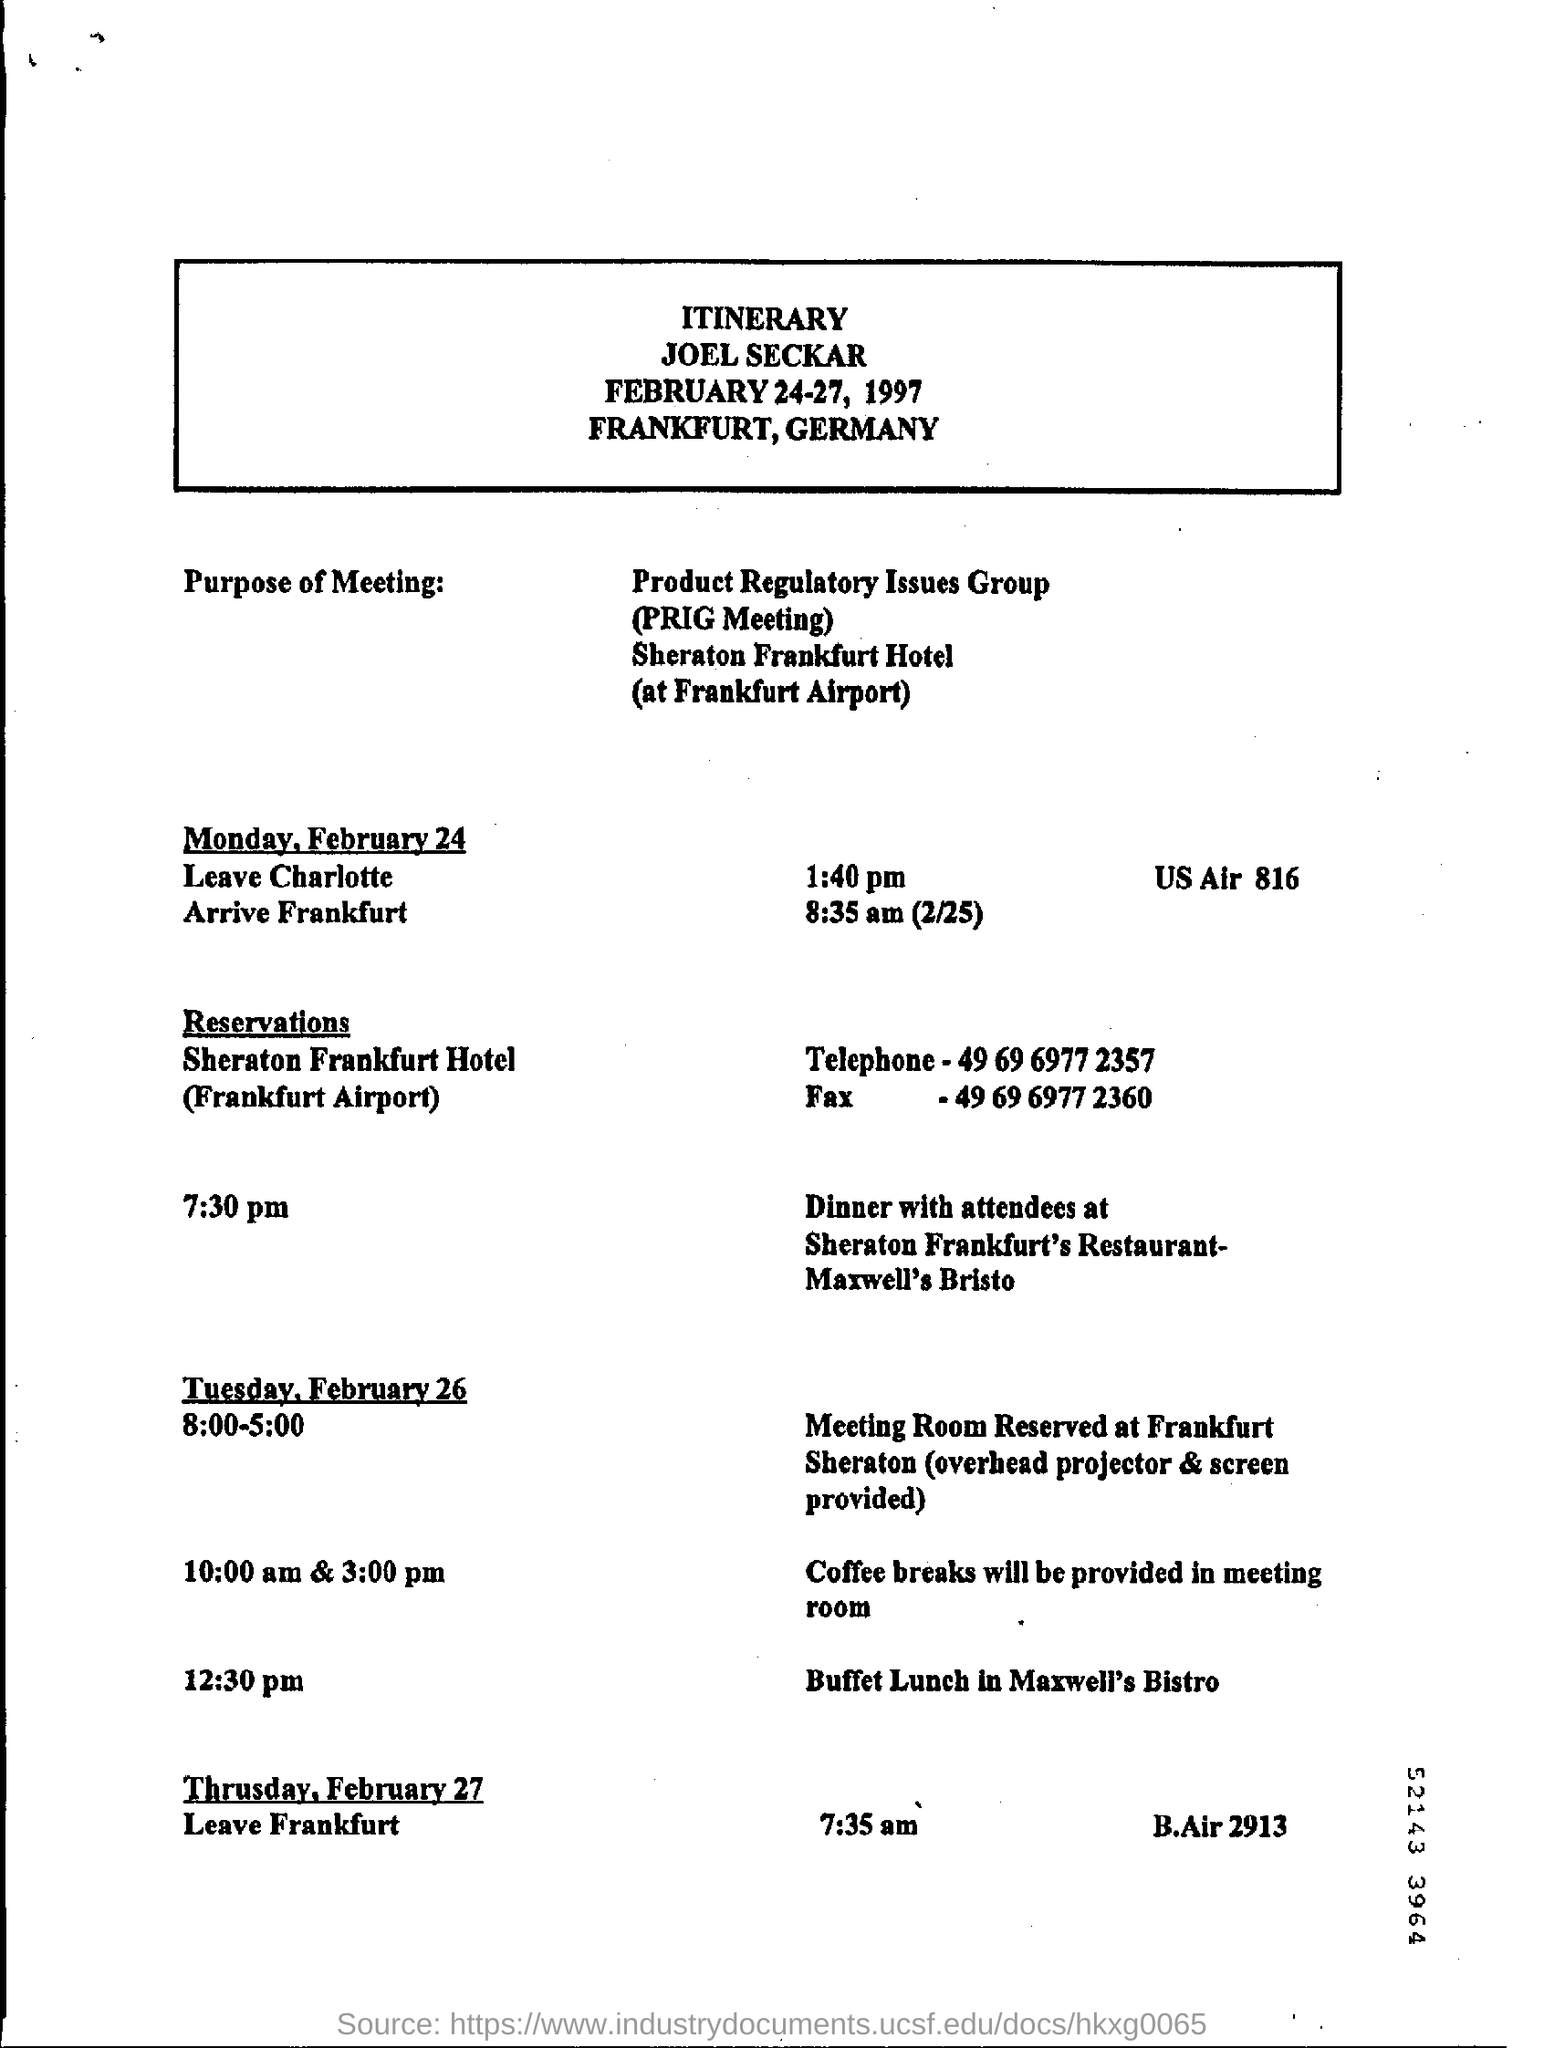List a handful of essential elements in this visual. The fullform of PRIG is Product Regulatory Issues Group. Frankfurt is located in Germany. The time mentioned to leave Frankfurt is 7.35 a.m. The time mentioned for leaving Charlotte is 1:40 pm. The buffet lunch will be arranged at Maxwell's Bistro. 